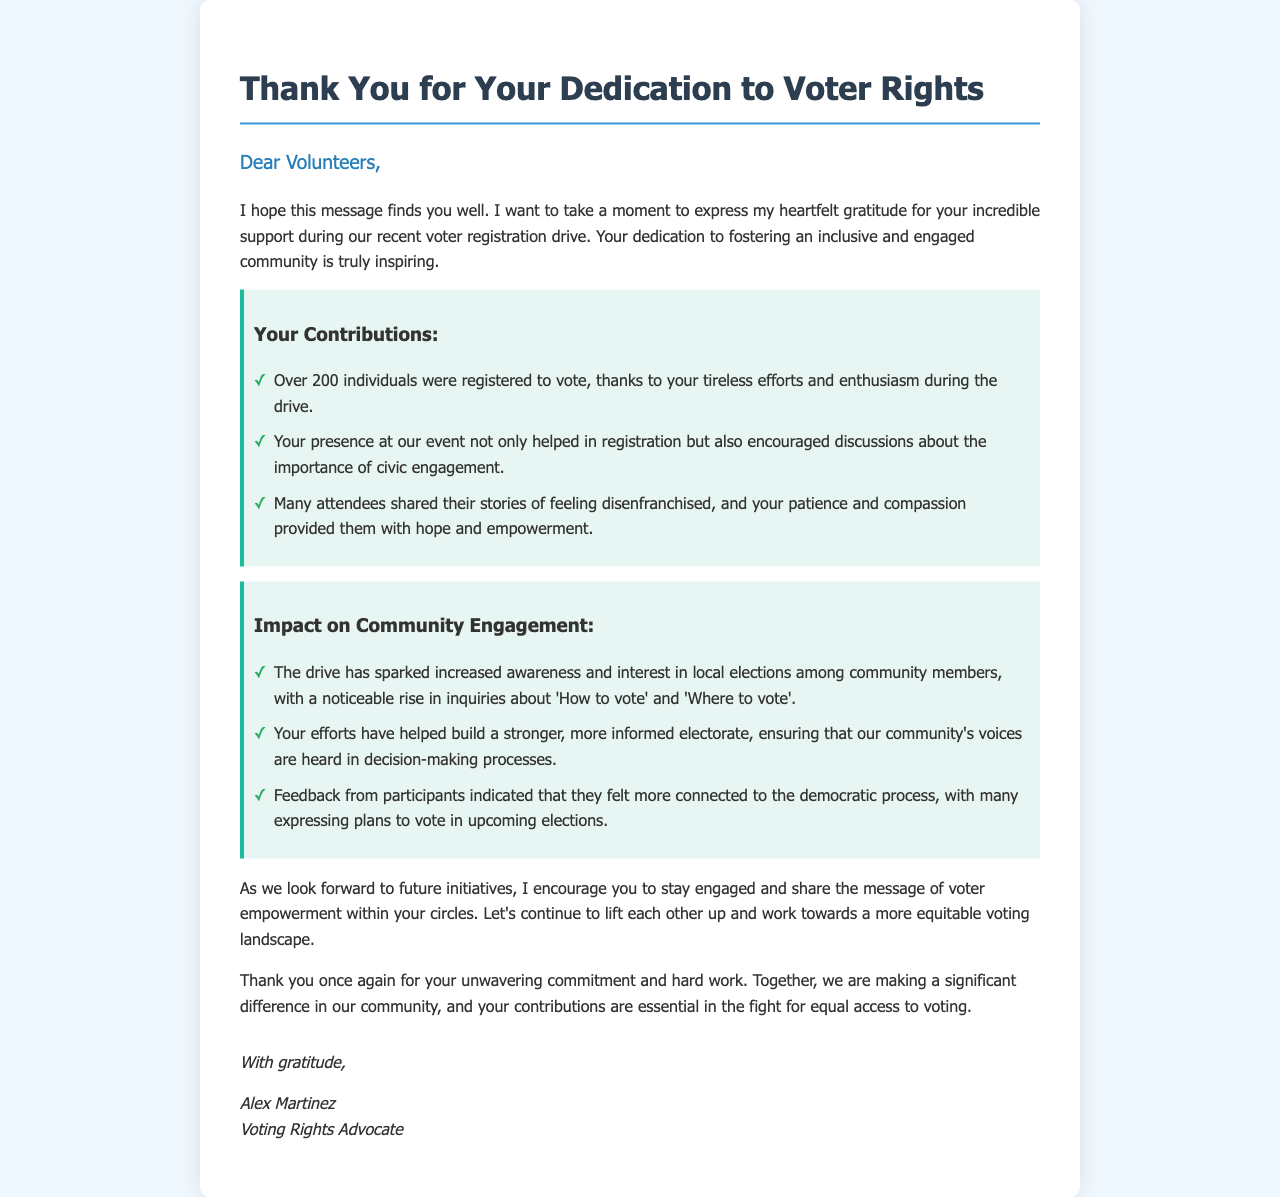What is the title of the letter? The title of the letter is the first heading in the document.
Answer: Thank You for Your Dedication to Voter Rights Who is the letter addressed to? The salutation in the letter indicates the audience of the message.
Answer: Volunteers How many individuals were registered to vote during the drive? The document states a specific number of individuals who were registered as a result of the efforts.
Answer: Over 200 What does the letter express gratitude for? The content highlights what the author is thankful for, particularly related to an event.
Answer: Support during the recent voter registration drive Who authored the letter? The closing section provides the name of the person who wrote the letter.
Answer: Alex Martinez What impact did the drive have on local elections? The letter describes a specific change in community member behavior regarding elections.
Answer: Increased awareness and interest What kind of feedback did participants provide? The letter references the responses from those involved to illustrate the drive's effectiveness.
Answer: More connected to the democratic process What message does the author encourage the volunteers to share? The content discusses a theme the author believes volunteers should promote.
Answer: Voter empowerment 